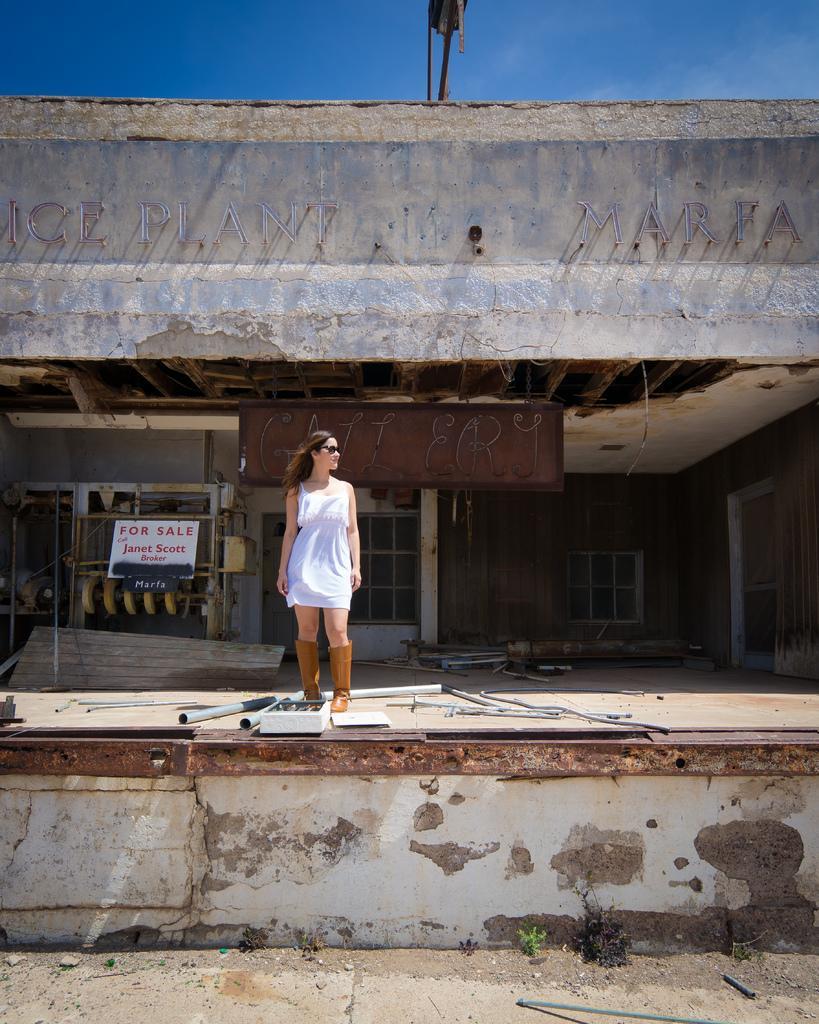How would you summarize this image in a sentence or two? There is a woman standing and we can see wall, rods and objects on the surface. In the background we can see boards, windows and there are few things. We can see sky. 